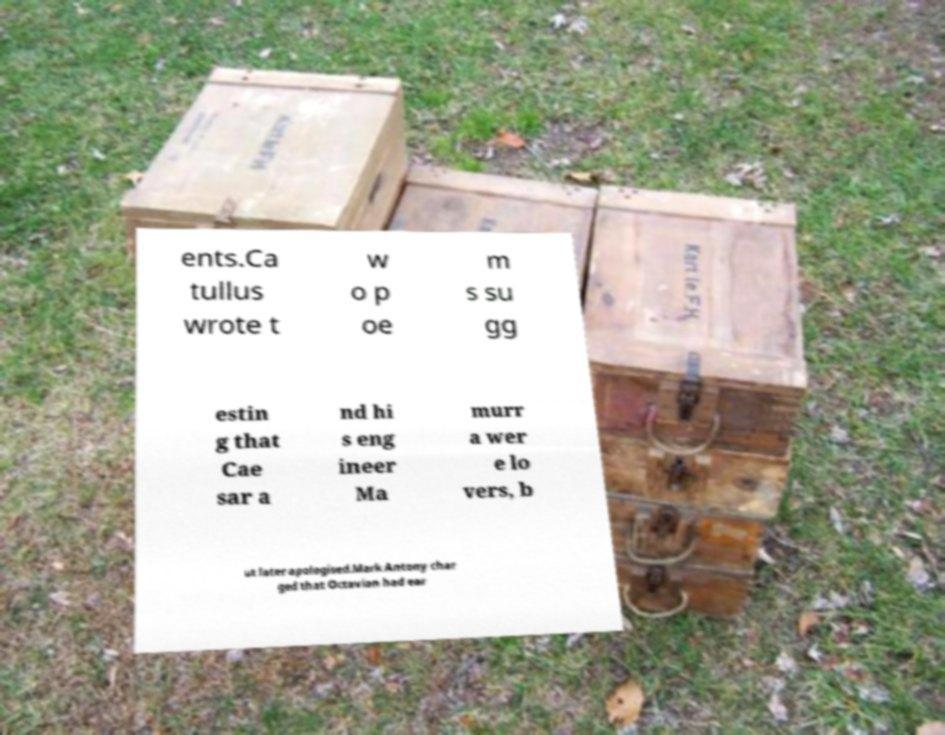Please identify and transcribe the text found in this image. ents.Ca tullus wrote t w o p oe m s su gg estin g that Cae sar a nd hi s eng ineer Ma murr a wer e lo vers, b ut later apologised.Mark Antony char ged that Octavian had ear 